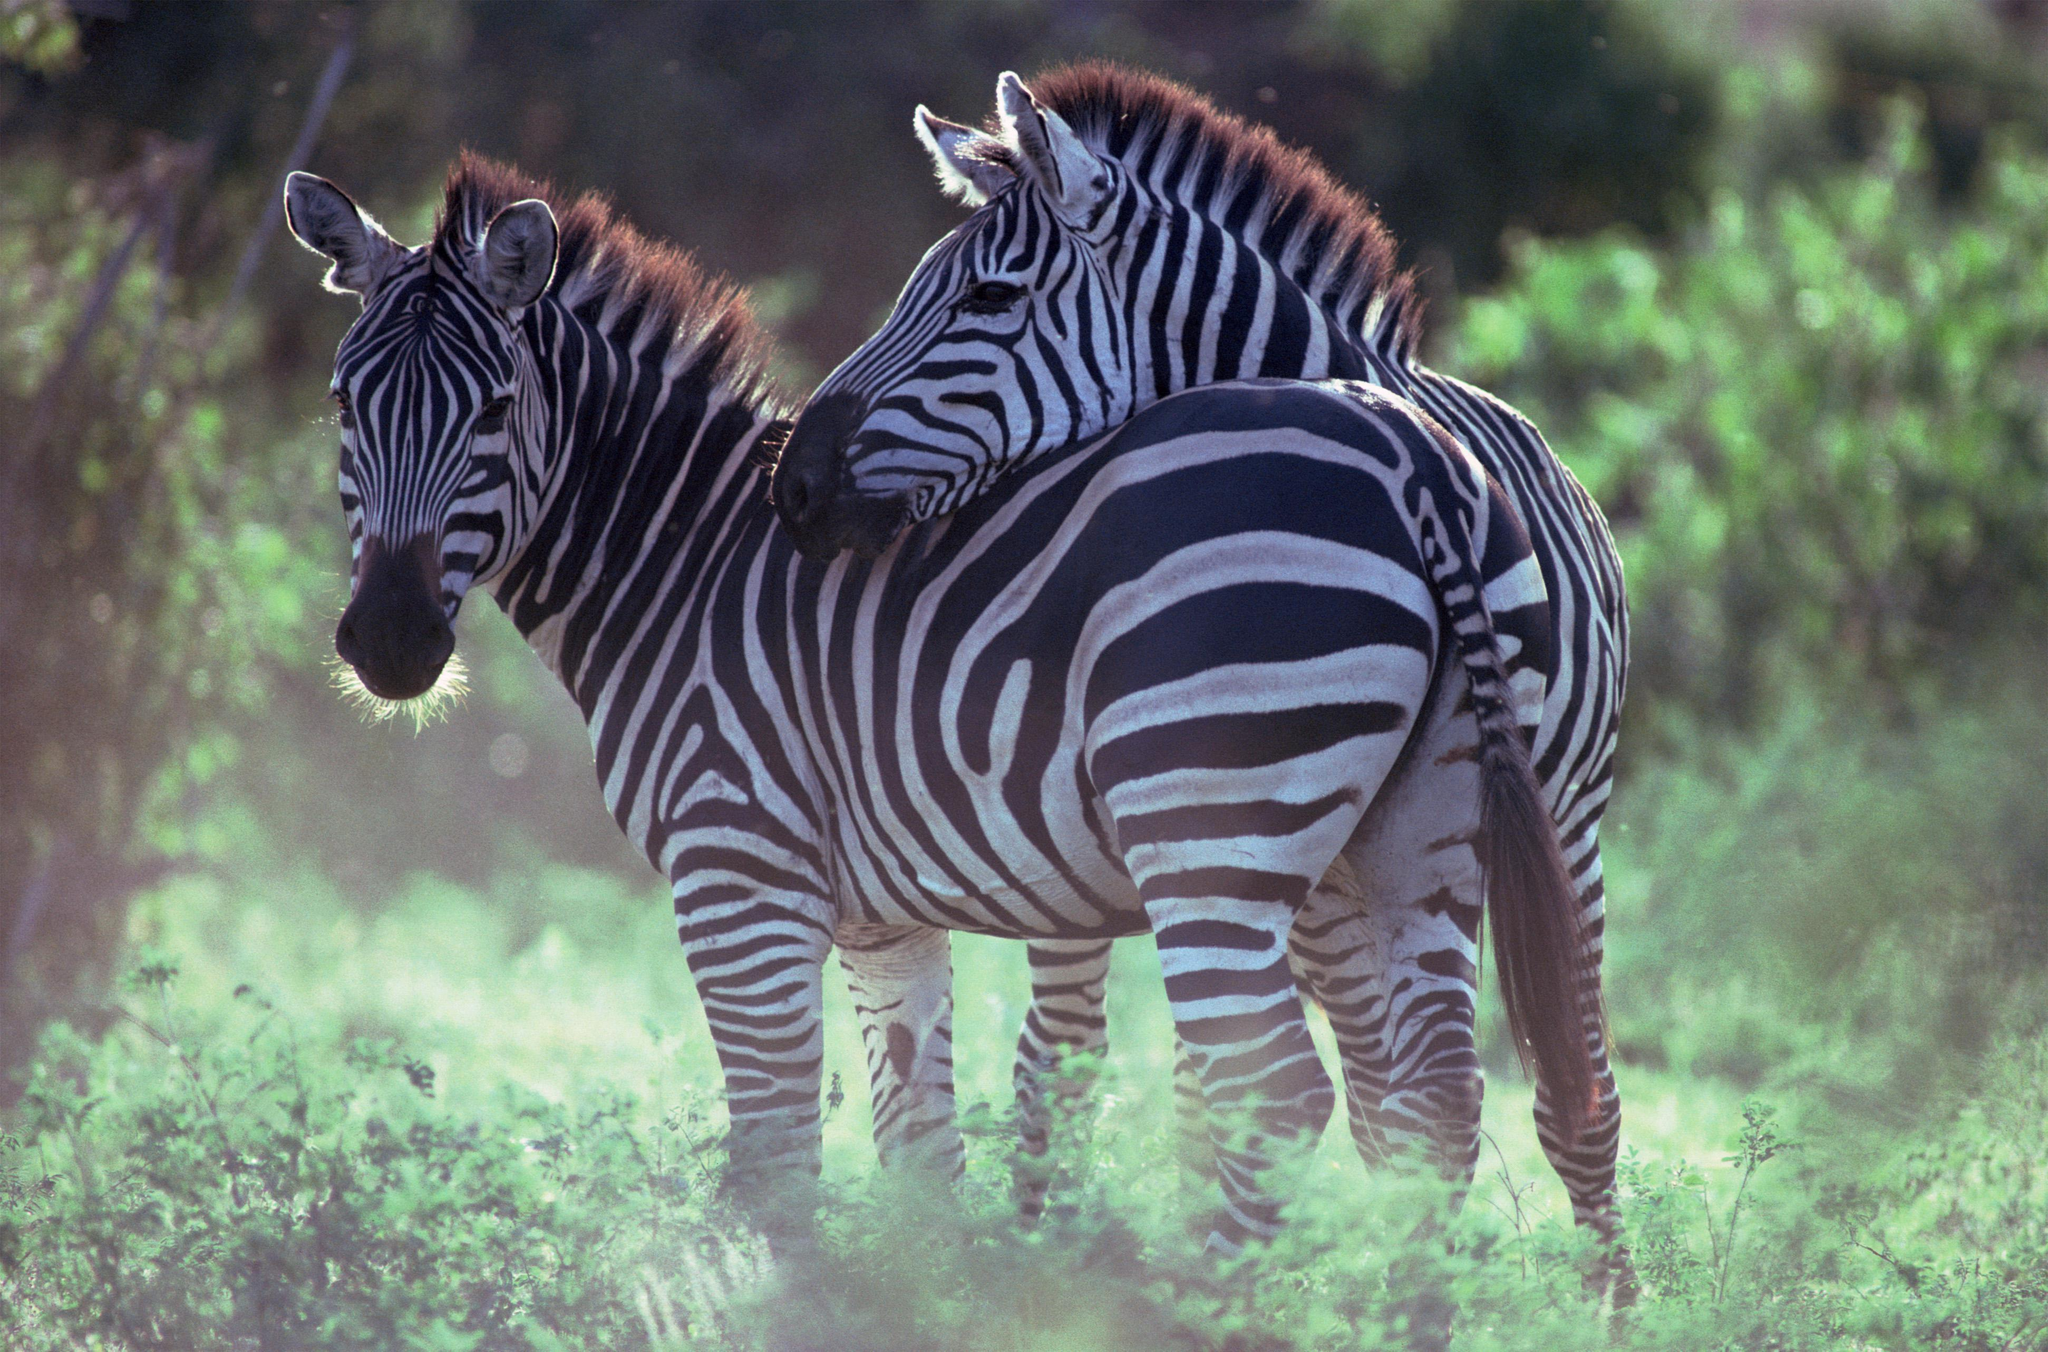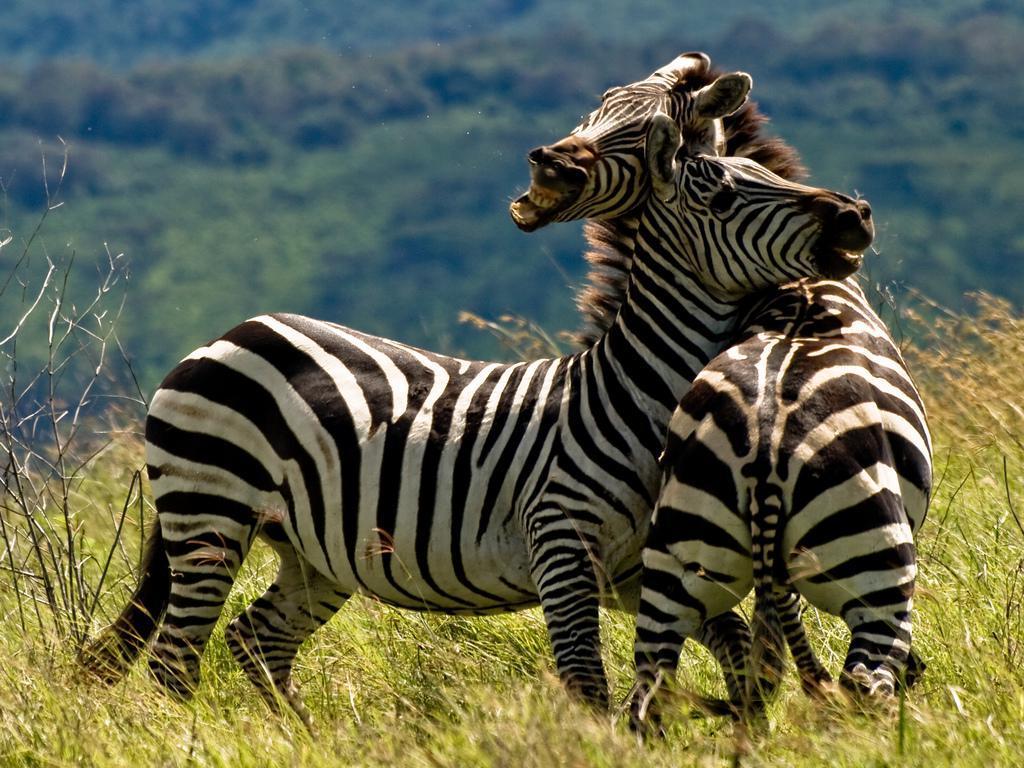The first image is the image on the left, the second image is the image on the right. For the images shown, is this caption "At least one baby zebra is staying close to its mom." true? Answer yes or no. No. The first image is the image on the left, the second image is the image on the right. Examine the images to the left and right. Is the description "Each image contains two zebras of similar size, and in at least one image, the head of one zebra is over the back of the other zebra." accurate? Answer yes or no. Yes. 